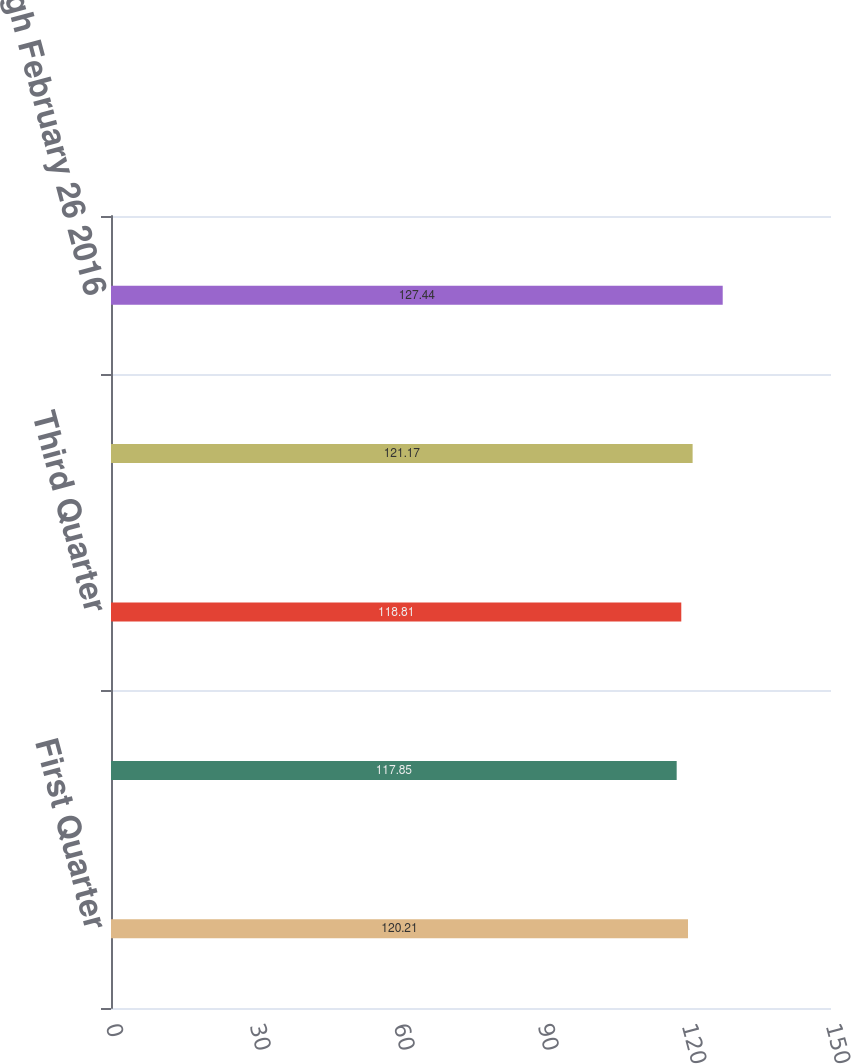<chart> <loc_0><loc_0><loc_500><loc_500><bar_chart><fcel>First Quarter<fcel>Second Quarter<fcel>Third Quarter<fcel>Fourth Quarter<fcel>Through February 26 2016<nl><fcel>120.21<fcel>117.85<fcel>118.81<fcel>121.17<fcel>127.44<nl></chart> 